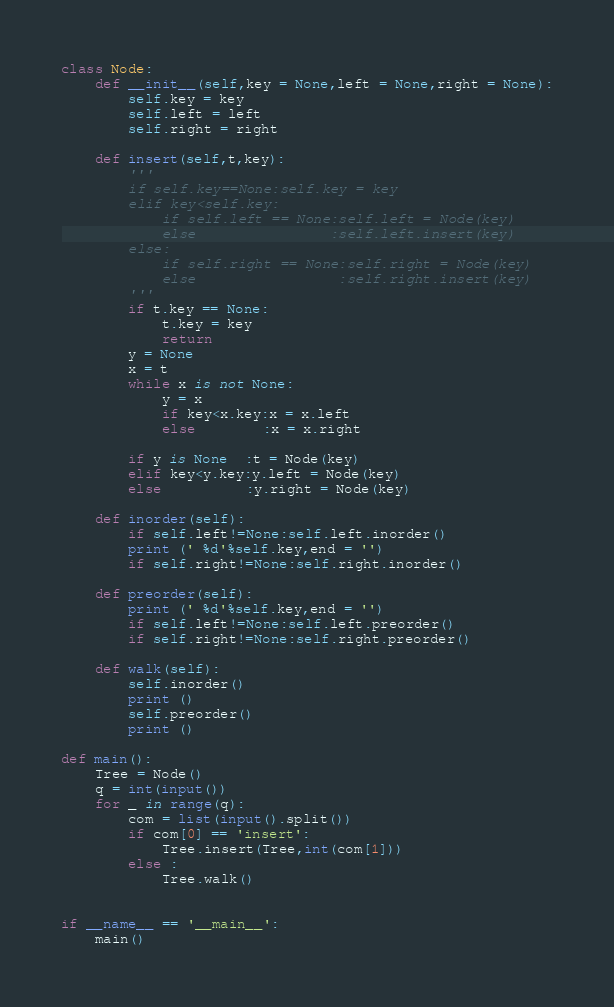Convert code to text. <code><loc_0><loc_0><loc_500><loc_500><_Python_>class Node:
    def __init__(self,key = None,left = None,right = None):
        self.key = key
        self.left = left
        self.right = right

    def insert(self,t,key):
        '''
        if self.key==None:self.key = key
        elif key<self.key:
            if self.left == None:self.left = Node(key)
            else                :self.left.insert(key)
        else:
            if self.right == None:self.right = Node(key)
            else                 :self.right.insert(key)
        '''
        if t.key == None:
            t.key = key
            return
        y = None 
        x = t
        while x is not None:
            y = x
            if key<x.key:x = x.left
            else        :x = x.right

        if y is None  :t = Node(key)
        elif key<y.key:y.left = Node(key)
        else          :y.right = Node(key)

    def inorder(self):
        if self.left!=None:self.left.inorder()
        print (' %d'%self.key,end = '')
        if self.right!=None:self.right.inorder()

    def preorder(self):
        print (' %d'%self.key,end = '')
        if self.left!=None:self.left.preorder()
        if self.right!=None:self.right.preorder()

    def walk(self):
        self.inorder()
        print ()
        self.preorder()
        print ()

def main():
    Tree = Node()
    q = int(input())
    for _ in range(q):
        com = list(input().split())
        if com[0] == 'insert':
            Tree.insert(Tree,int(com[1]))
        else :
            Tree.walk()


if __name__ == '__main__':
    main()


</code> 